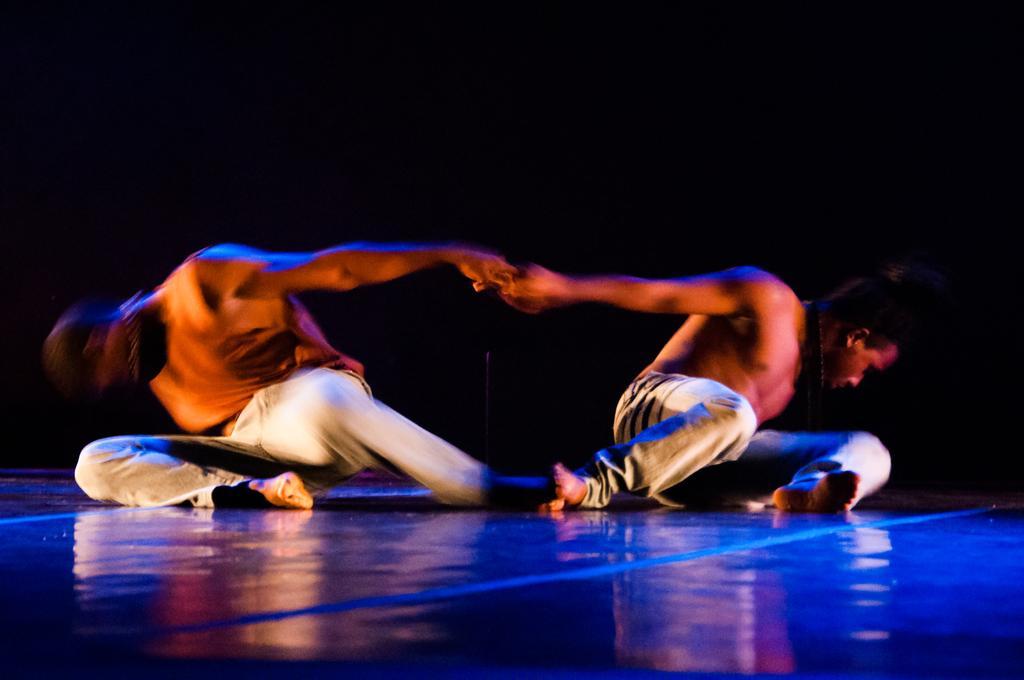Can you describe this image briefly? In this picture there are two people and there might be dancing. At the bottom there is a floor. At the back there is a black background. 